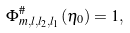<formula> <loc_0><loc_0><loc_500><loc_500>\Phi ^ { \# } _ { m , l , l _ { 2 } , l _ { 1 } } ( \eta _ { 0 } ) = 1 ,</formula> 